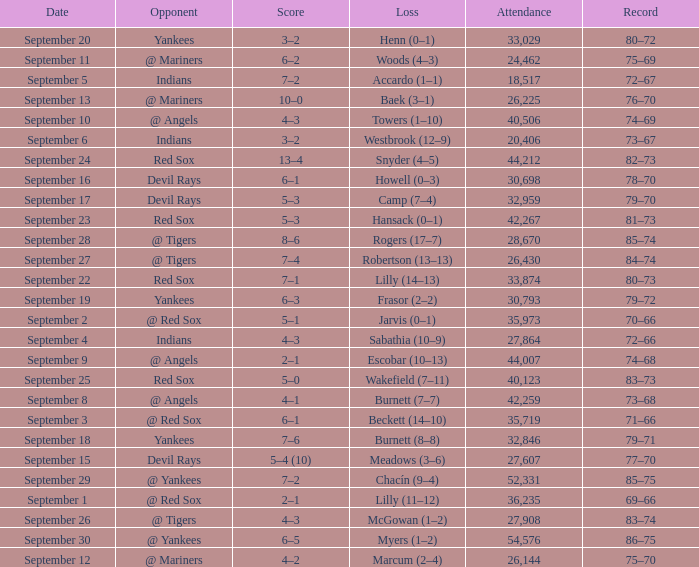Which opponent plays on September 19? Yankees. 